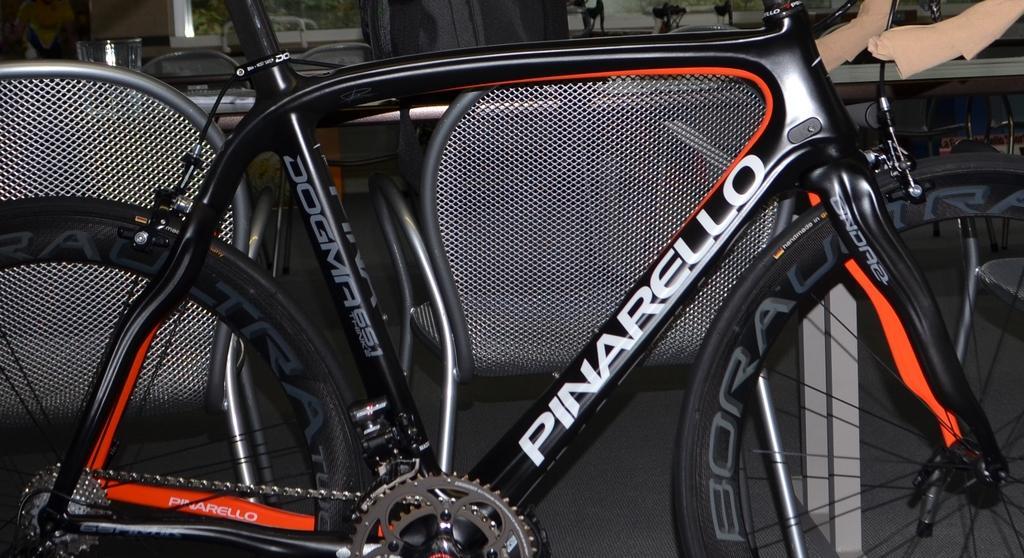Could you give a brief overview of what you see in this image? In this image, we can see a bicycle and in the background, there is a glass and we can see some other objects. 